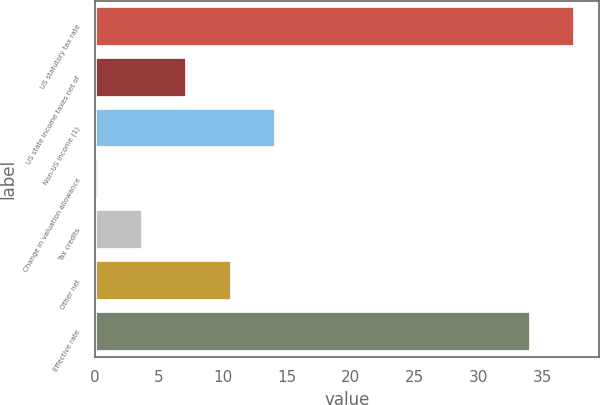Convert chart to OTSL. <chart><loc_0><loc_0><loc_500><loc_500><bar_chart><fcel>US statutory tax rate<fcel>US state income taxes net of<fcel>Non-US income (1)<fcel>Change in valuation allowance<fcel>Tax credits<fcel>Other net<fcel>Effective rate<nl><fcel>37.57<fcel>7.24<fcel>14.18<fcel>0.3<fcel>3.77<fcel>10.71<fcel>34.1<nl></chart> 